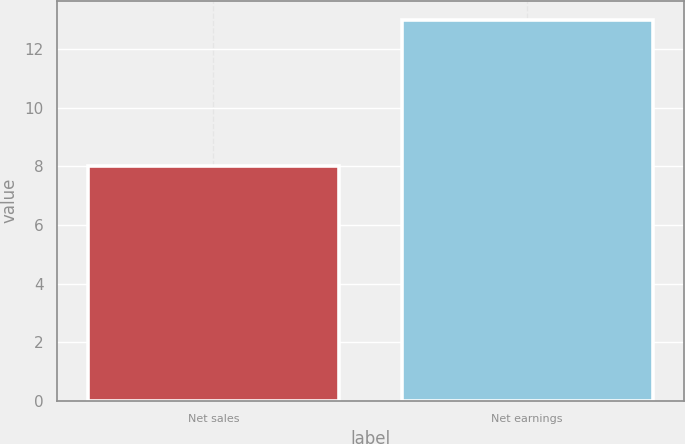Convert chart. <chart><loc_0><loc_0><loc_500><loc_500><bar_chart><fcel>Net sales<fcel>Net earnings<nl><fcel>8<fcel>13<nl></chart> 